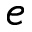<formula> <loc_0><loc_0><loc_500><loc_500>e</formula> 